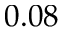Convert formula to latex. <formula><loc_0><loc_0><loc_500><loc_500>0 . 0 8</formula> 